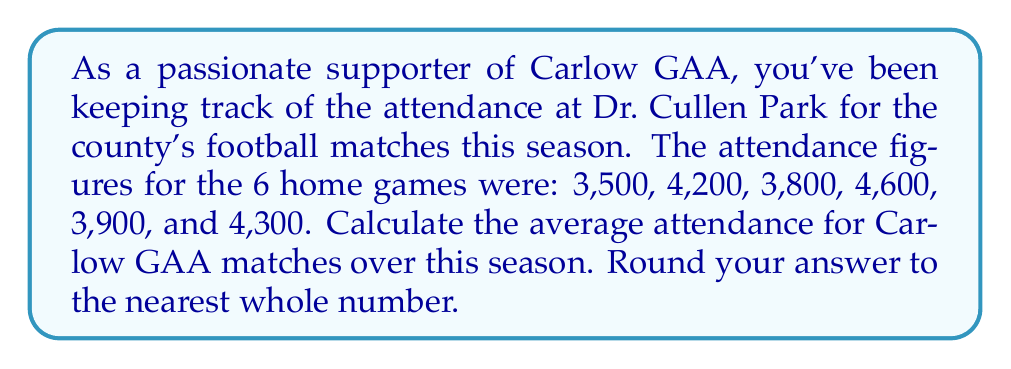Can you solve this math problem? To calculate the average attendance, we need to:
1. Sum up all the attendance figures
2. Divide the sum by the number of games

Let's go through this step-by-step:

1. Sum of attendances:
   $$3,500 + 4,200 + 3,800 + 4,600 + 3,900 + 4,300 = 24,300$$

2. Number of games: 6

3. Calculate the average:
   $$\text{Average} = \frac{\text{Sum of attendances}}{\text{Number of games}}$$
   $$\text{Average} = \frac{24,300}{6} = 4,050$$

4. Round to the nearest whole number:
   4,050 is already a whole number, so no rounding is necessary.

Therefore, the average attendance for Carlow GAA matches over the season was 4,050 people.
Answer: $4,050$ people 